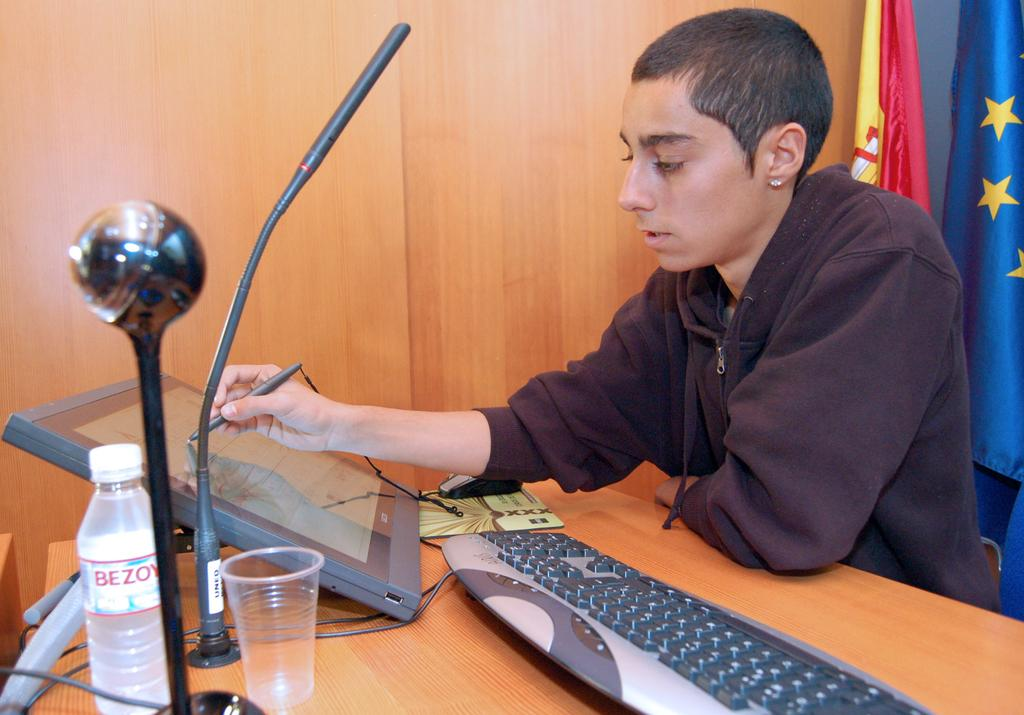Provide a one-sentence caption for the provided image. A tan man in a brown sweatshirt drawing on a large tablet and a Bezoy water bottle on the desk. 